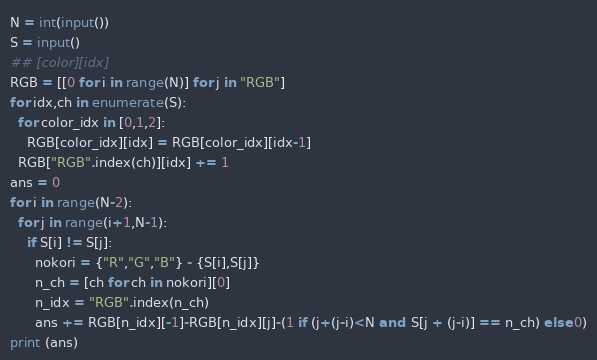Convert code to text. <code><loc_0><loc_0><loc_500><loc_500><_Python_>N = int(input())
S = input()
## [color][idx]
RGB = [[0 for i in range(N)] for j in "RGB"]
for idx,ch in enumerate(S):
  for color_idx in [0,1,2]:
    RGB[color_idx][idx] = RGB[color_idx][idx-1]
  RGB["RGB".index(ch)][idx] += 1
ans = 0
for i in range(N-2):
  for j in range(i+1,N-1):
    if S[i] != S[j]:
      nokori = {"R","G","B"} - {S[i],S[j]}
      n_ch = [ch for ch in nokori][0]
      n_idx = "RGB".index(n_ch)
      ans += RGB[n_idx][-1]-RGB[n_idx][j]-(1 if (j+(j-i)<N and  S[j + (j-i)] == n_ch) else 0)
print (ans)</code> 